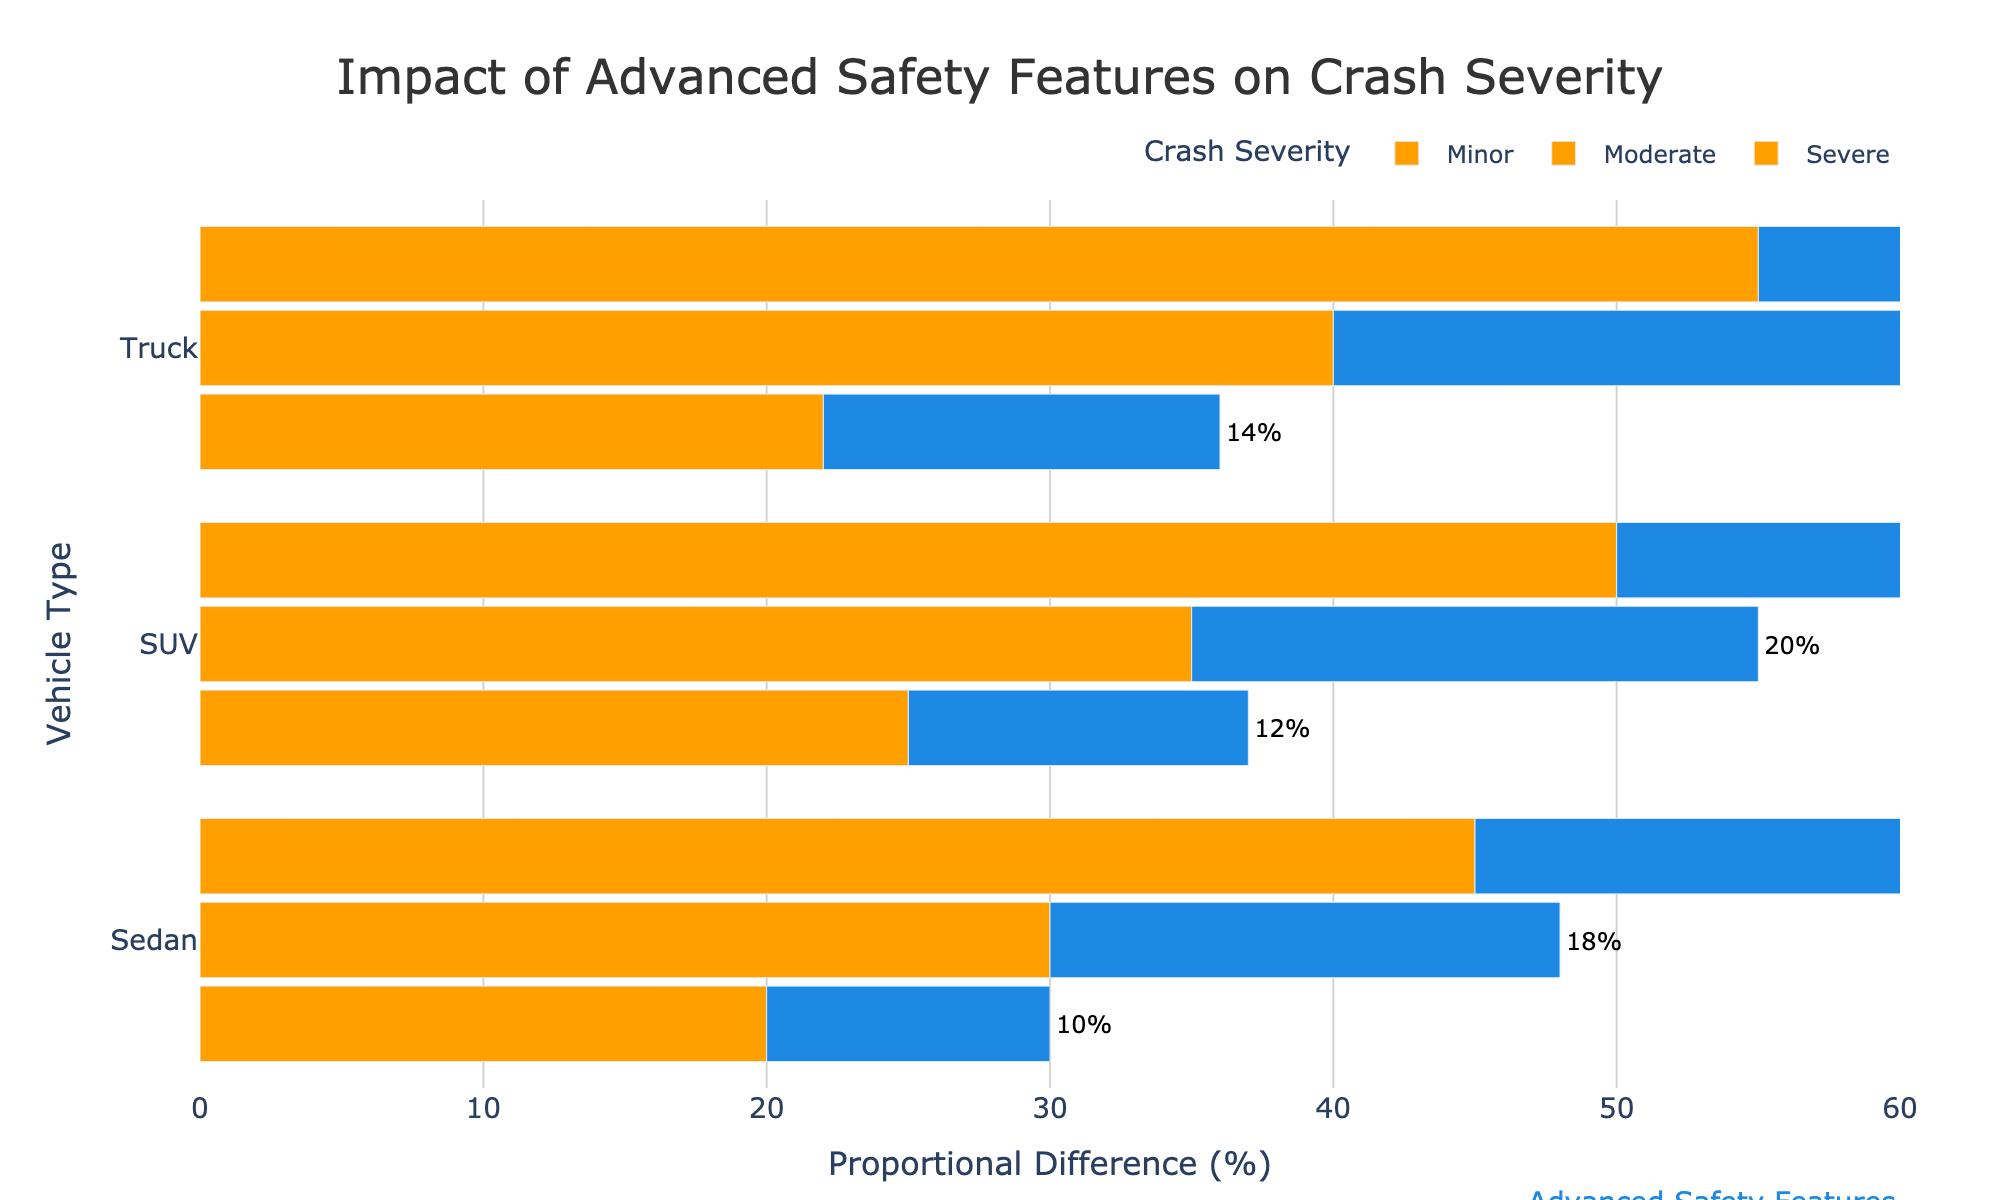What is the proportional difference in severe crashes for SUVs with basic safety features compared to those with advanced safety features? The figure lists the proportional difference in severe crashes for SUVs with basic safety features as 50% and with advanced safety features as 32%. The difference between these is 50% - 32% = 18%.
Answer: 18% Which vehicle type shows the largest reduction in minor crash severity when equipped with advanced safety features? In the figure, Sedans show a reduction from 20% (basic) to 10% (advanced), SUVs from 25% to 12%, and Trucks from 22% to 14%. The largest reduction is observed in SUVs with a reduction of 25% - 12% = 13%.
Answer: SUVs What's the average proportional difference in moderate crash severity for trucks with basic and advanced safety features? The figure shows trucks with basic safety features having a proportional difference of 40% and with advanced safety features, 25%. The average is calculated as (40% + 25%) / 2 = 65% / 2 = 32.5%.
Answer: 32.5% Is there a vehicle type where all severity levels had over 30% difference for basic safety features while also showing significant proportional differences for advanced safety features? The figure shows that for trucks with basic safety features, all crash severity levels (minor: 22%, moderate: 40%, severe: 55%) exceed 30% in at least one instance. In the case of trucks with advanced safety features, the differences are (minor: 14%, moderate: 25%, and severe: 35%), with only severe crashes above 30%.
Answer: No Which vehicle type has the smallest visual difference in bar length between minor and severe crash severities when equipped with advanced safety features? The figure indicates the lengths of the bars represent proportional differences. For sedans, the minor (10%) vs severe (30%) difference is 20%. For SUVs, minor (12%) vs severe (32%) is 20%. For trucks, minor (14%) vs severe (35%) is 21%. The smallest visual difference is found in sedans and SUVs, both at 20%.
Answer: Sedans and SUVs 